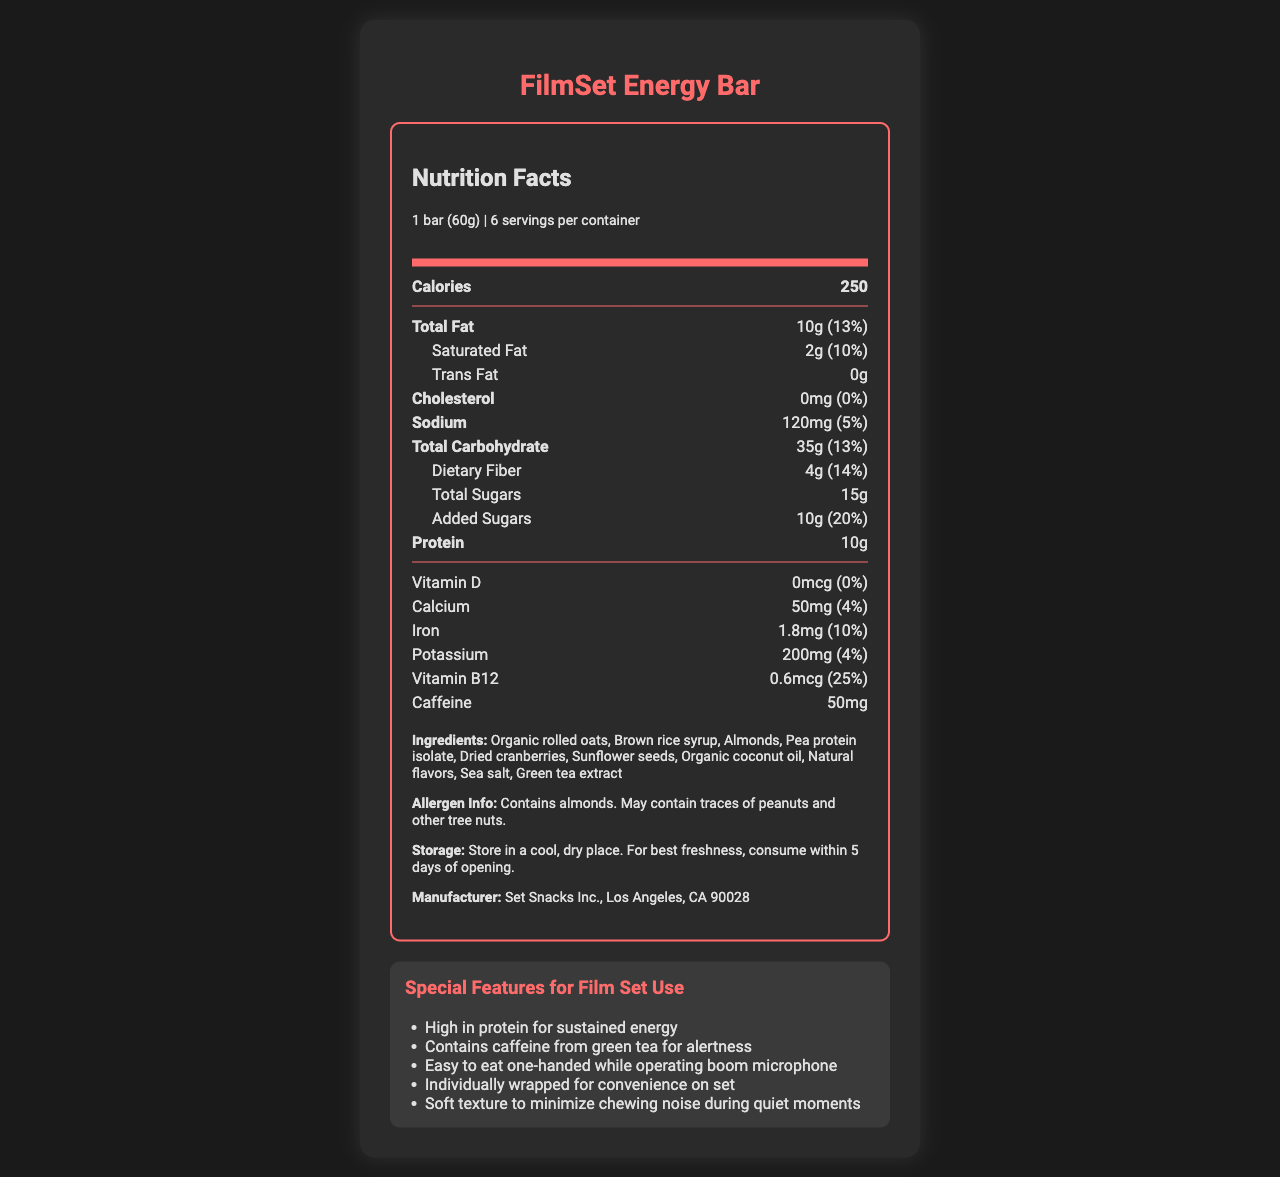what is the serving size for the FilmSet Energy Bar? The serving size is clearly listed as "1 bar (60g)" under the serving information section.
Answer: 1 bar (60g) how many servings are there per container? The document specifies that there are 6 servings per container in the serving information section.
Answer: 6 how many calories are in one serving of the FilmSet Energy Bar? The document lists that each serving contains 250 calories in the bold section specifying "Calories".
Answer: 250 what is the amount of protein in one bar? The amount of protein is listed as "10g" under the nutrient row labeled "Protein".
Answer: 10g what allergens are present in the FilmSet Energy Bar? The allergen information section states that the bar contains almonds and may contain traces of peanuts and other tree nuts.
Answer: Contains almonds. May contain traces of peanuts and other tree nuts. which ingredient provides the caffeine content in the FilmSet Energy Bar? The ingredient list includes "Green tea extract," which is noted as a source of caffeine.
Answer: Green tea extract is there any cholesterol in the FilmSet Energy Bar? (Yes/No) The nutrition label indicates that the amount of cholesterol is 0mg, meaning there is no cholesterol.
Answer: No which of the following is a special feature of the FilmSet Energy Bar for film set use? A. Contains artificial flavors B. Individually wrapped for convenience on set C. Low in protein The document lists "Individually wrapped for convenience on set" as one of the special features for film set use.
Answer: B what is the total daily value percentage of calcium provided in one bar? A. 4% B. 14% C. 10% D. 25% The document lists the daily value percentage for calcium as 4%.
Answer: A what is the storage instruction for the FilmSet Energy Bar? The storage instructions are clearly listed under the instructions section.
Answer: Store in a cool, dry place. For best freshness, consume within 5 days of opening. What are the main features and nutritional components of the FilmSet Energy Bar? The document provides details on the serving size, nutritional content, ingredients, allergen information, special features, and storage instructions.
Answer: The FilmSet Energy Bar is designed for optimal use on film sets, with high protein content (10g) for sustained energy, contains caffeine (50mg) for alertness, and is easy to eat one-handed. It has 250 calories, 10g of total fat, and various vitamins and minerals. It is also free from cholesterol, contains dietary fiber (4g), added sugars (10g), and is individually wrapped. what is the exact vitamin B12 content in one bar? The document lists the vitamin B12 content as 0.6mcg in the nutrient row labeled "Vitamin B12".
Answer: 0.6mcg who manufactures the FilmSet Energy Bar? The manufacturer information is listed as "Set Snacks Inc., Los Angeles, CA 90028".
Answer: Set Snacks Inc., Los Angeles, CA 90028 what is the purpose of the ingredient "brown rice syrup"? The document lists "Brown rice syrup" as an ingredient but does not specify its purpose.
Answer: Not enough information which feature minimizes chewing noise during quiet moments on set? One of the listed special features for film set use is that the bar has a soft texture to minimize chewing noise during quiet moments.
Answer: Soft texture 